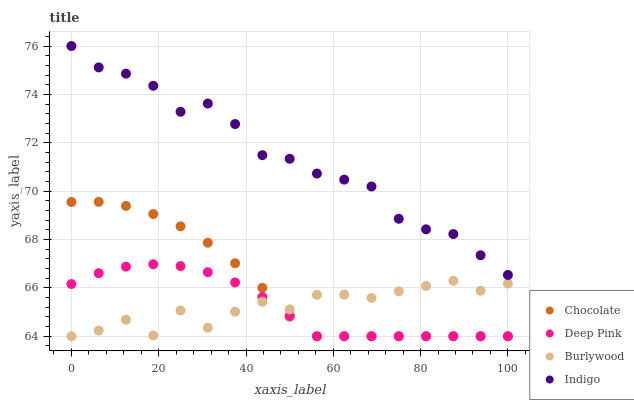Does Deep Pink have the minimum area under the curve?
Answer yes or no. Yes. Does Indigo have the maximum area under the curve?
Answer yes or no. Yes. Does Indigo have the minimum area under the curve?
Answer yes or no. No. Does Deep Pink have the maximum area under the curve?
Answer yes or no. No. Is Deep Pink the smoothest?
Answer yes or no. Yes. Is Burlywood the roughest?
Answer yes or no. Yes. Is Indigo the smoothest?
Answer yes or no. No. Is Indigo the roughest?
Answer yes or no. No. Does Burlywood have the lowest value?
Answer yes or no. Yes. Does Indigo have the lowest value?
Answer yes or no. No. Does Indigo have the highest value?
Answer yes or no. Yes. Does Deep Pink have the highest value?
Answer yes or no. No. Is Chocolate less than Indigo?
Answer yes or no. Yes. Is Indigo greater than Deep Pink?
Answer yes or no. Yes. Does Deep Pink intersect Burlywood?
Answer yes or no. Yes. Is Deep Pink less than Burlywood?
Answer yes or no. No. Is Deep Pink greater than Burlywood?
Answer yes or no. No. Does Chocolate intersect Indigo?
Answer yes or no. No. 